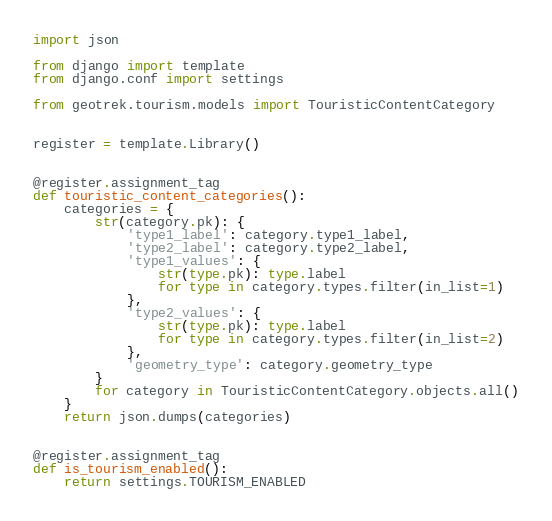<code> <loc_0><loc_0><loc_500><loc_500><_Python_>import json

from django import template
from django.conf import settings

from geotrek.tourism.models import TouristicContentCategory


register = template.Library()


@register.assignment_tag
def touristic_content_categories():
    categories = {
        str(category.pk): {
            'type1_label': category.type1_label,
            'type2_label': category.type2_label,
            'type1_values': {
                str(type.pk): type.label
                for type in category.types.filter(in_list=1)
            },
            'type2_values': {
                str(type.pk): type.label
                for type in category.types.filter(in_list=2)
            },
            'geometry_type': category.geometry_type
        }
        for category in TouristicContentCategory.objects.all()
    }
    return json.dumps(categories)


@register.assignment_tag
def is_tourism_enabled():
    return settings.TOURISM_ENABLED
</code> 